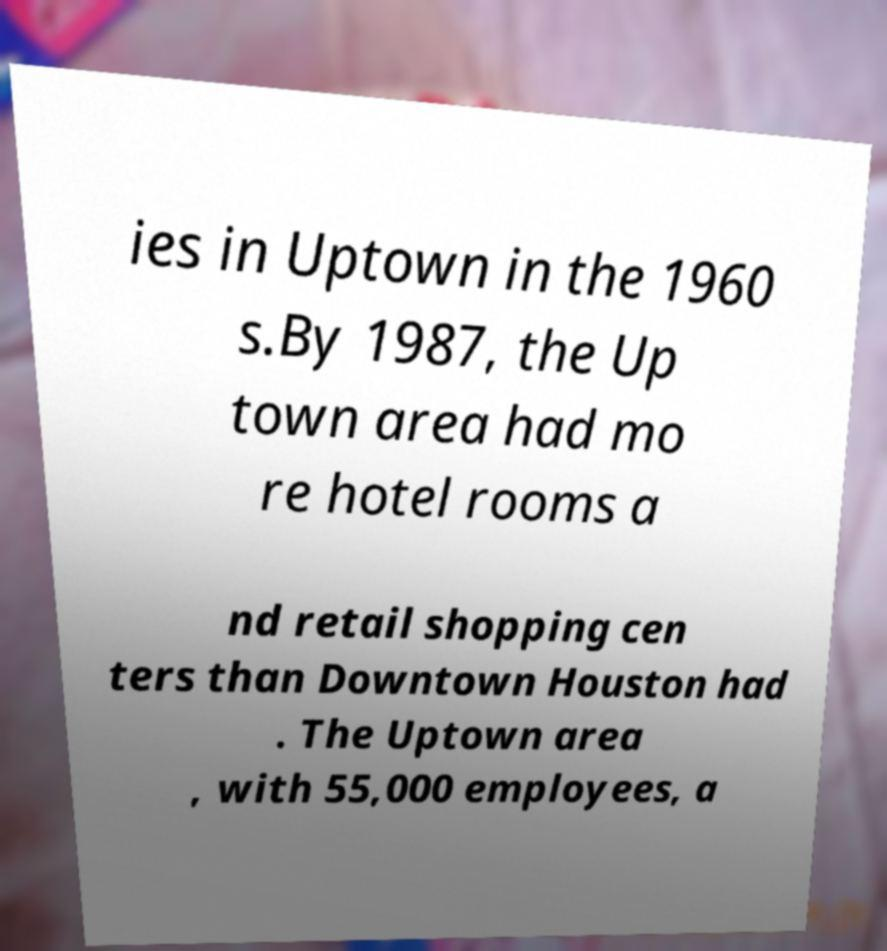Can you accurately transcribe the text from the provided image for me? ies in Uptown in the 1960 s.By 1987, the Up town area had mo re hotel rooms a nd retail shopping cen ters than Downtown Houston had . The Uptown area , with 55,000 employees, a 